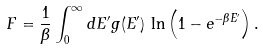<formula> <loc_0><loc_0><loc_500><loc_500>F = { \frac { 1 } { \beta } } \int _ { 0 } ^ { \infty } d E ^ { \prime } g ( E ^ { \prime } ) \, \ln \left ( 1 - e ^ { - \beta E ^ { \prime } } \right ) .</formula> 